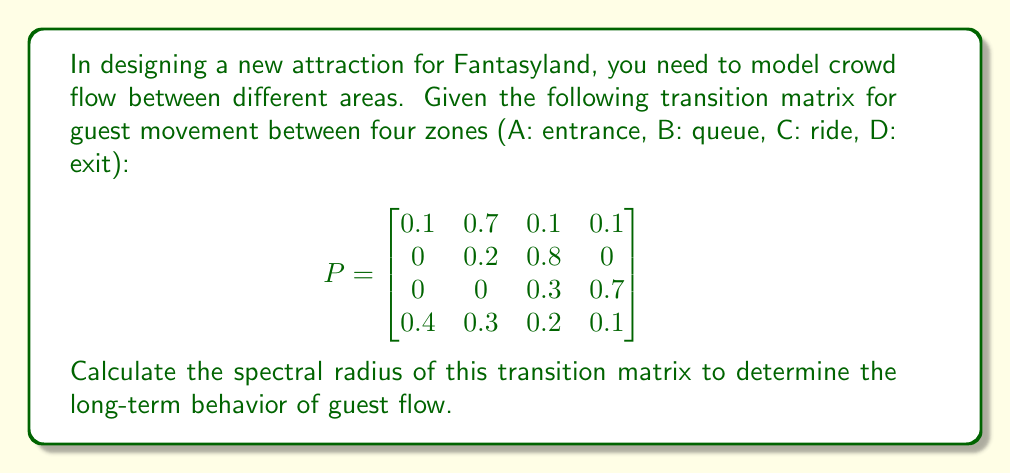Can you solve this math problem? To find the spectral radius of the transition matrix P, we need to follow these steps:

1) First, we need to calculate the eigenvalues of the matrix. The characteristic equation is:

   $$det(P - \lambda I) = 0$$

2) Expanding this determinant:

   $$\begin{vmatrix}
   0.1-\lambda & 0.7 & 0.1 & 0.1 \\
   0 & 0.2-\lambda & 0.8 & 0 \\
   0 & 0 & 0.3-\lambda & 0.7 \\
   0.4 & 0.3 & 0.2 & 0.1-\lambda
   \end{vmatrix} = 0$$

3) This expands to the polynomial:

   $$\lambda^4 - 0.7\lambda^3 - 0.23\lambda^2 + 0.0532\lambda - 0.0028 = 0$$

4) Solving this equation (using a computer algebra system due to its complexity) gives us the eigenvalues:

   $$\lambda_1 \approx 1, \lambda_2 \approx -0.1616, \lambda_3 \approx -0.0692 + 0.1616i, \lambda_4 \approx -0.0692 - 0.1616i$$

5) The spectral radius is the maximum absolute value of these eigenvalues:

   $$\rho(P) = \max\{|\lambda_1|, |\lambda_2|, |\lambda_3|, |\lambda_4|\}$$

6) Calculating the absolute values:

   $$|\lambda_1| \approx 1, |\lambda_2| \approx 0.1616, |\lambda_3| = |\lambda_4| \approx 0.1758$$

7) The maximum of these values is 1.

Therefore, the spectral radius of the transition matrix is 1.
Answer: 1 